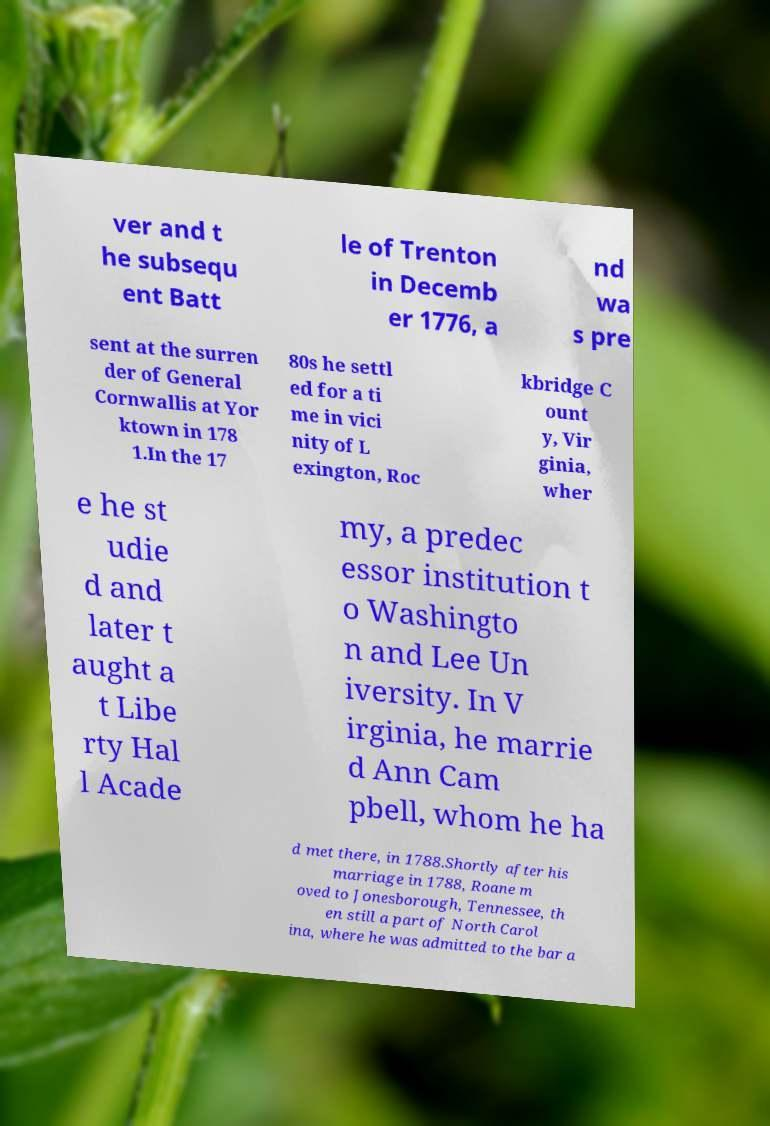For documentation purposes, I need the text within this image transcribed. Could you provide that? ver and t he subsequ ent Batt le of Trenton in Decemb er 1776, a nd wa s pre sent at the surren der of General Cornwallis at Yor ktown in 178 1.In the 17 80s he settl ed for a ti me in vici nity of L exington, Roc kbridge C ount y, Vir ginia, wher e he st udie d and later t aught a t Libe rty Hal l Acade my, a predec essor institution t o Washingto n and Lee Un iversity. In V irginia, he marrie d Ann Cam pbell, whom he ha d met there, in 1788.Shortly after his marriage in 1788, Roane m oved to Jonesborough, Tennessee, th en still a part of North Carol ina, where he was admitted to the bar a 